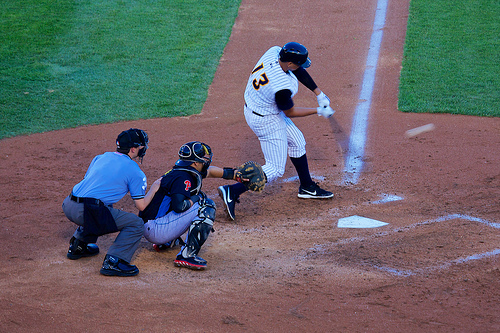Are there umpires behind the catcher? Yes, there are umpires positioned strategically behind the catcher to monitor the game closely. 